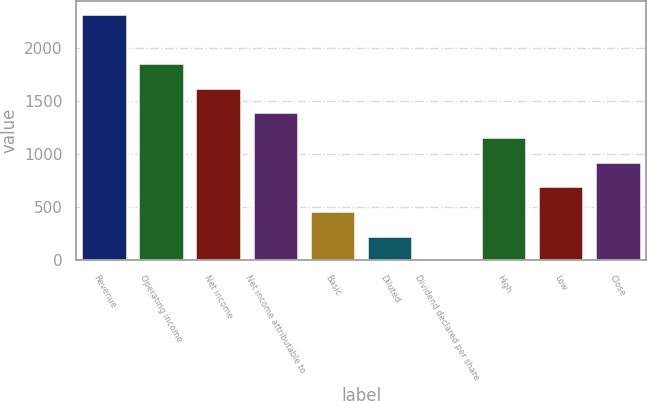Convert chart. <chart><loc_0><loc_0><loc_500><loc_500><bar_chart><fcel>Revenue<fcel>Operating income<fcel>Net income<fcel>Net income attributable to<fcel>Basic<fcel>Diluted<fcel>Dividend declared per share<fcel>High<fcel>Low<fcel>Close<nl><fcel>2320<fcel>1856.3<fcel>1624.45<fcel>1392.6<fcel>465.2<fcel>233.35<fcel>1.5<fcel>1160.75<fcel>697.05<fcel>928.9<nl></chart> 